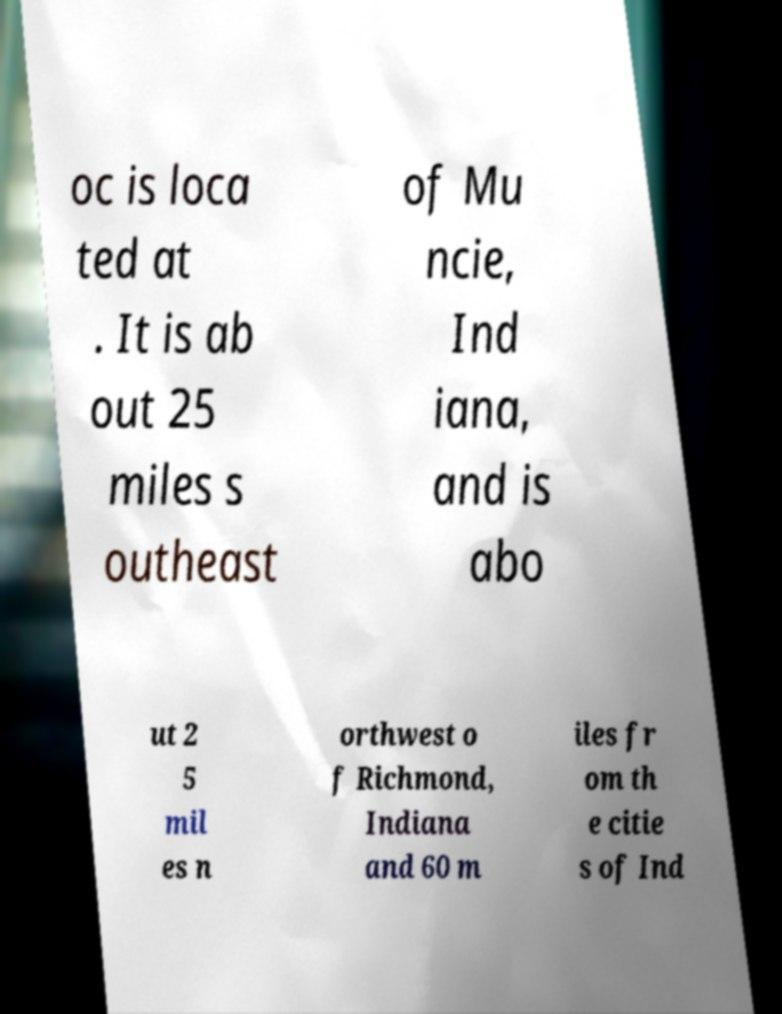Please read and relay the text visible in this image. What does it say? oc is loca ted at . It is ab out 25 miles s outheast of Mu ncie, Ind iana, and is abo ut 2 5 mil es n orthwest o f Richmond, Indiana and 60 m iles fr om th e citie s of Ind 